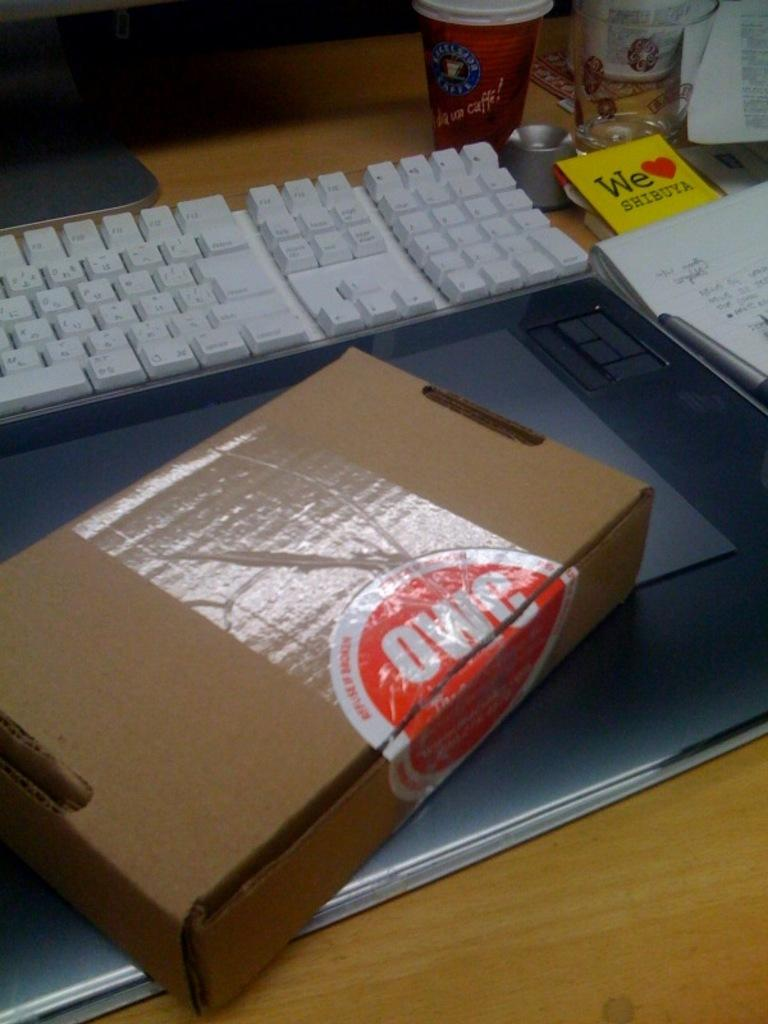<image>
Share a concise interpretation of the image provided. A keyboard and notepad rest near a note that says We love Shibuya. 